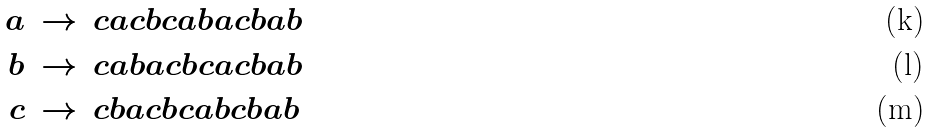Convert formula to latex. <formula><loc_0><loc_0><loc_500><loc_500>a & \, \rightarrow \, c a c b c a b a c b a b \\ b & \, \rightarrow \, c a b a c b c a c b a b \\ c & \, \rightarrow \, c b a c b c a b c b a b</formula> 